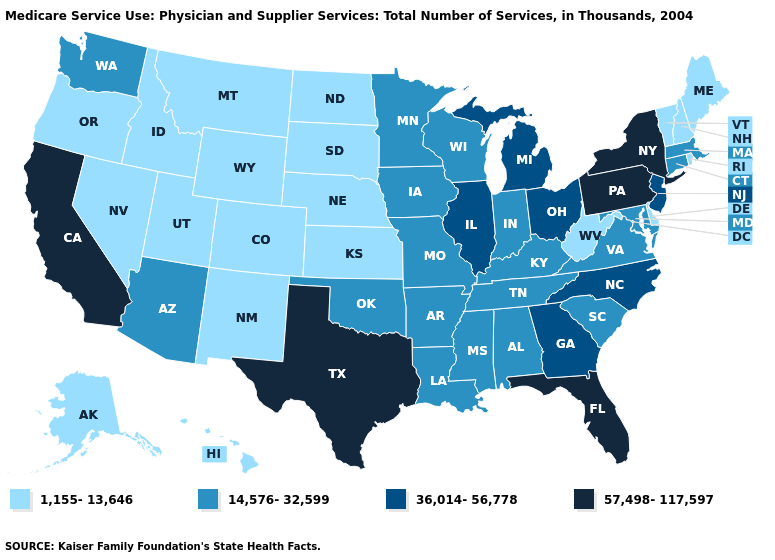Name the states that have a value in the range 14,576-32,599?
Short answer required. Alabama, Arizona, Arkansas, Connecticut, Indiana, Iowa, Kentucky, Louisiana, Maryland, Massachusetts, Minnesota, Mississippi, Missouri, Oklahoma, South Carolina, Tennessee, Virginia, Washington, Wisconsin. What is the value of Alaska?
Keep it brief. 1,155-13,646. Among the states that border Ohio , does West Virginia have the lowest value?
Give a very brief answer. Yes. What is the highest value in states that border Ohio?
Short answer required. 57,498-117,597. Name the states that have a value in the range 1,155-13,646?
Concise answer only. Alaska, Colorado, Delaware, Hawaii, Idaho, Kansas, Maine, Montana, Nebraska, Nevada, New Hampshire, New Mexico, North Dakota, Oregon, Rhode Island, South Dakota, Utah, Vermont, West Virginia, Wyoming. Does West Virginia have the lowest value in the USA?
Be succinct. Yes. What is the value of Idaho?
Answer briefly. 1,155-13,646. How many symbols are there in the legend?
Short answer required. 4. What is the highest value in the USA?
Be succinct. 57,498-117,597. Does Florida have the highest value in the South?
Quick response, please. Yes. Does Nebraska have the highest value in the USA?
Write a very short answer. No. What is the value of Idaho?
Short answer required. 1,155-13,646. Does Pennsylvania have the same value as New York?
Write a very short answer. Yes. What is the lowest value in the Northeast?
Write a very short answer. 1,155-13,646. What is the value of Nebraska?
Answer briefly. 1,155-13,646. 